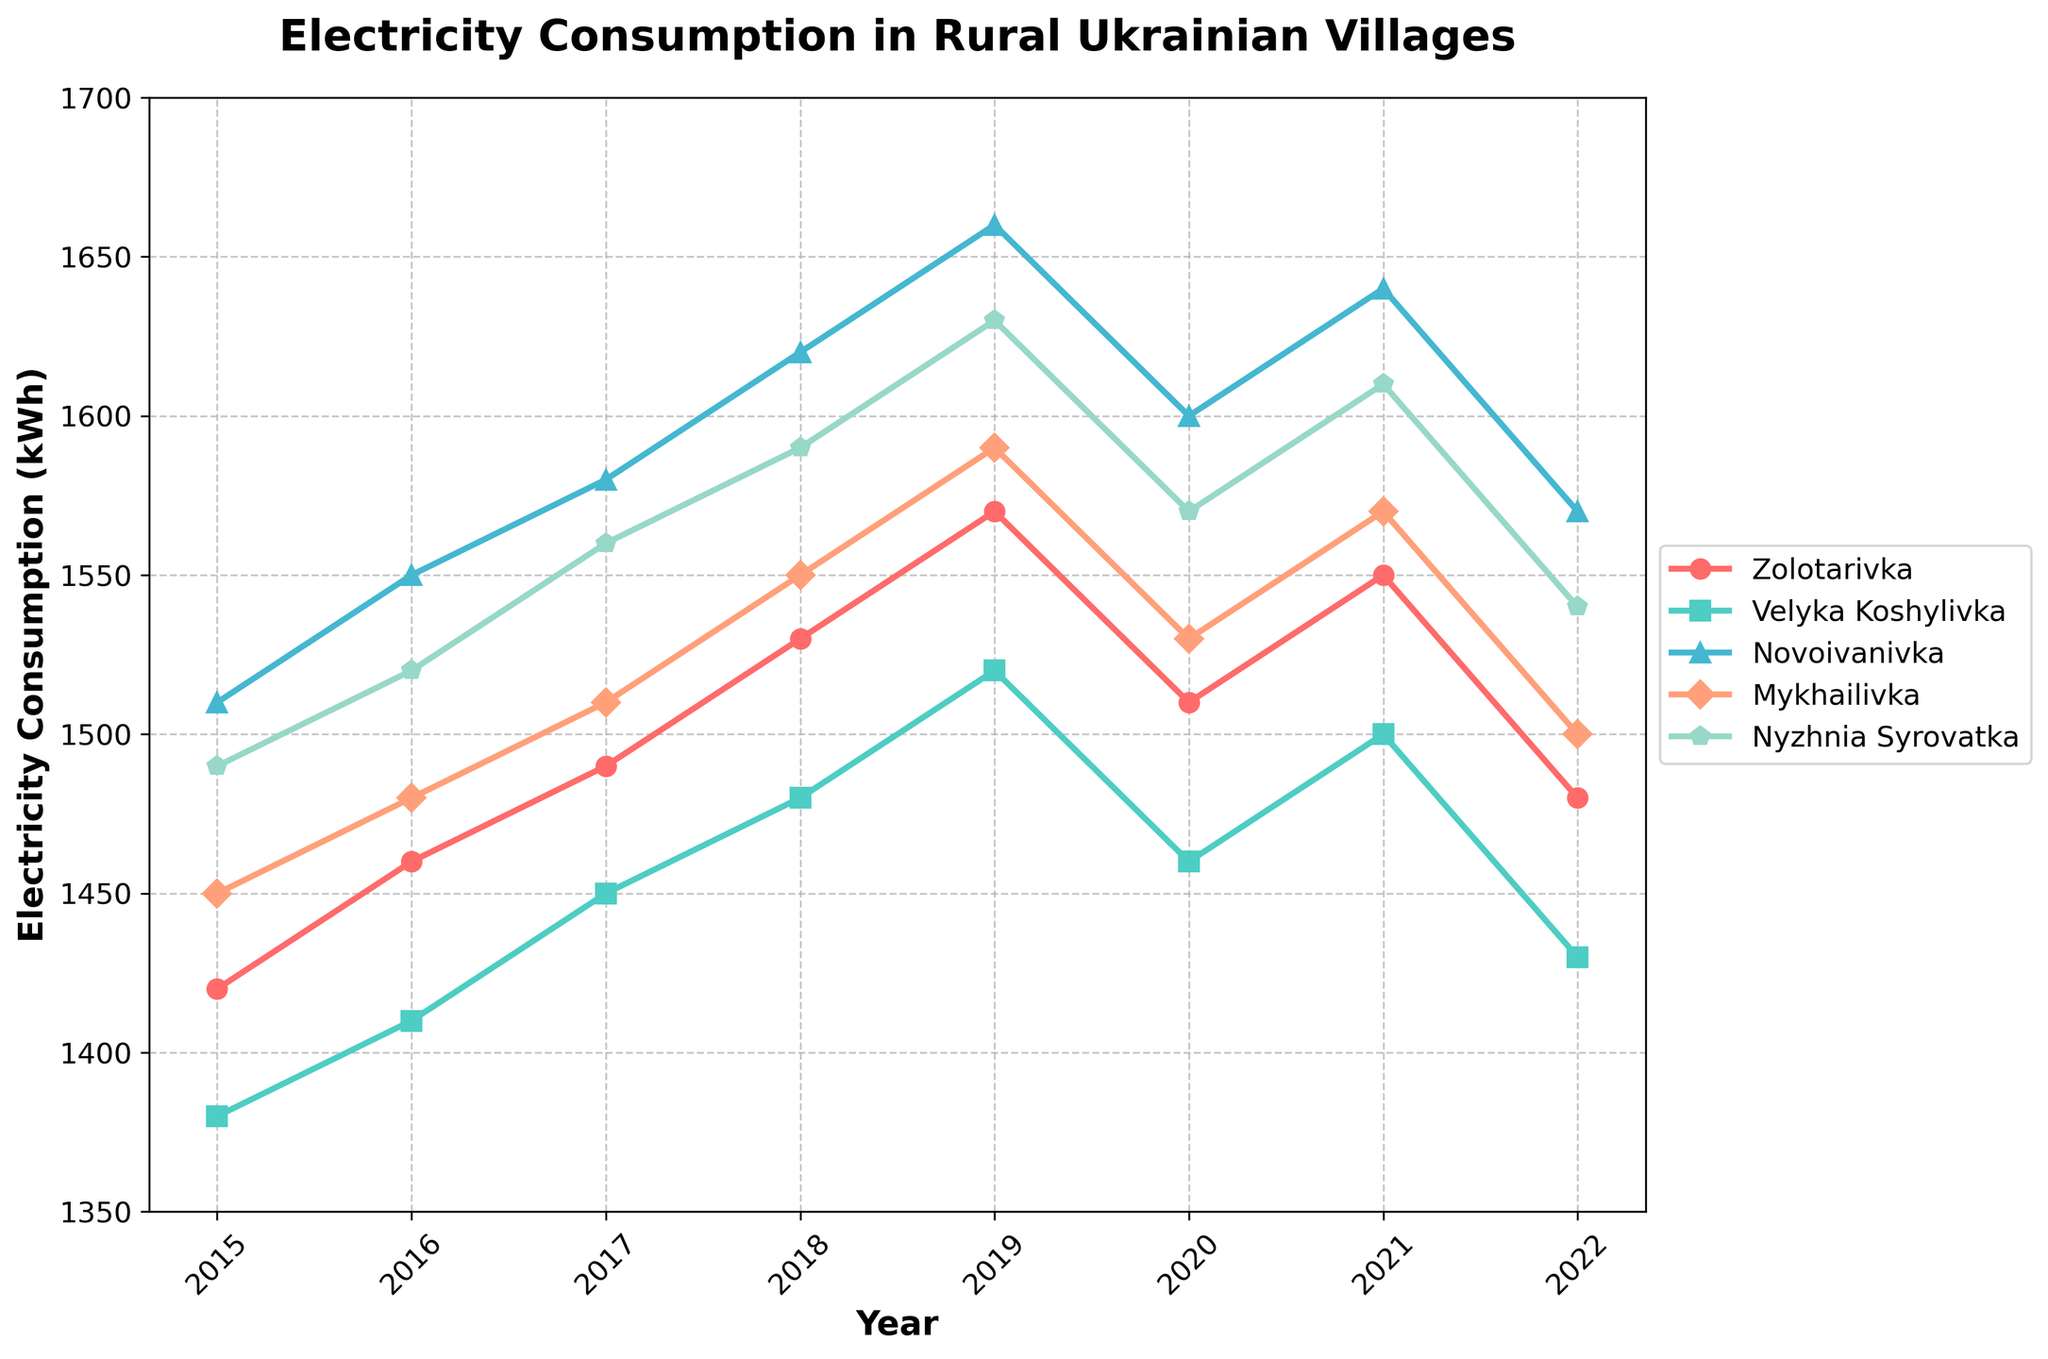Which village had the highest electricity consumption in 2019? The highest point in 2019 is the marker for Novoivanivka at 1660 kWh.
Answer: Novoivanivka How did the electricity consumption in Zolotarivka change from 2015 to 2022? In 2015, Zolotarivka consumed 1420 kWh, and in 2022, it consumed 1480 kWh. The change is 1480 - 1420 = 60 kWh increase.
Answer: 60 kWh increase Which year saw the lowest electricity consumption in Mykhailivka? The lowest point for Mykhailivka is in 2022 at 1500 kWh.
Answer: 2022 Compare the electricity consumption trends in Zolotarivka and Velyka Koshylivka. Which village had a more consistent trend over the years? Zolotarivka's yearly values: 1420, 1460, 1490, 1530, 1570, 1510, 1550, 1480. Velyka Koshylivka's yearly values: 1380, 1410, 1450, 1480, 1520, 1460, 1500, 1430. Both exhibit similar inconsistencies. Velyka Koshylivka's changes are less sharp compared to Zolotarivka's drop in 2020 and 2022.
Answer: Velyka Koshylivka In which year did all five villages have their highest electricity consumption collectively? Sum the electricity consumption values for each year and compare, the maximum combined consumption is the year: 
2015: 1420+1380+1510+1450+1490 = 7250
2016: 1460+1410+1550+1480+1520 = 7420
2017: 1490+1450+1580+1510+1560 = 7590
2018: 1530+1480+1620+1550+1590 = 7770
2019: 1570+1520+1660+1590+1630 = 7970
2020: 1510+1460+1600+1530+1570 = 7670
2021: 1550+1500+1640+1570+1610 = 7870
2022: 1480+1430+1570+1500+1540 = 7520
Hence, 2019 has the highest combined consumption.
Answer: 2019 In which years did Zolotarivka have a higher electricity consumption than Novoivanivka? Compare yearly values and note where Zolotarivka's values exceed Novoivanivka's values. 
Zolotarivka: 1420, 1460, 1490, 1530, 1570, 1510, 1550, 1480
Novoivanivka: 1510, 1550, 1580, 1620, 1660, 1600, 1640, 1570
There is no year where Zolotarivka's value exceeds Novoivanivka’s value.
Answer: None 